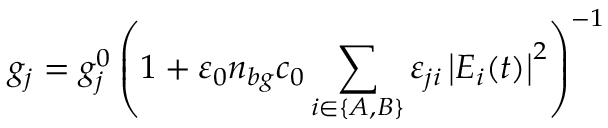Convert formula to latex. <formula><loc_0><loc_0><loc_500><loc_500>g _ { j } = g _ { j } ^ { 0 } \left ( 1 + \varepsilon _ { 0 } n _ { b g } c _ { 0 } \sum _ { i \in \{ A , B \} } \varepsilon _ { j i } \left | E _ { i } ( t ) \right | ^ { 2 } \right ) ^ { - 1 }</formula> 